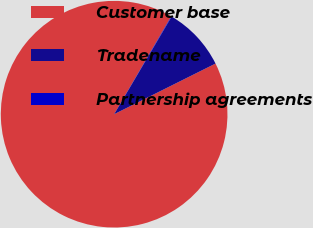Convert chart to OTSL. <chart><loc_0><loc_0><loc_500><loc_500><pie_chart><fcel>Customer base<fcel>Tradename<fcel>Partnership agreements<nl><fcel>90.78%<fcel>9.15%<fcel>0.07%<nl></chart> 